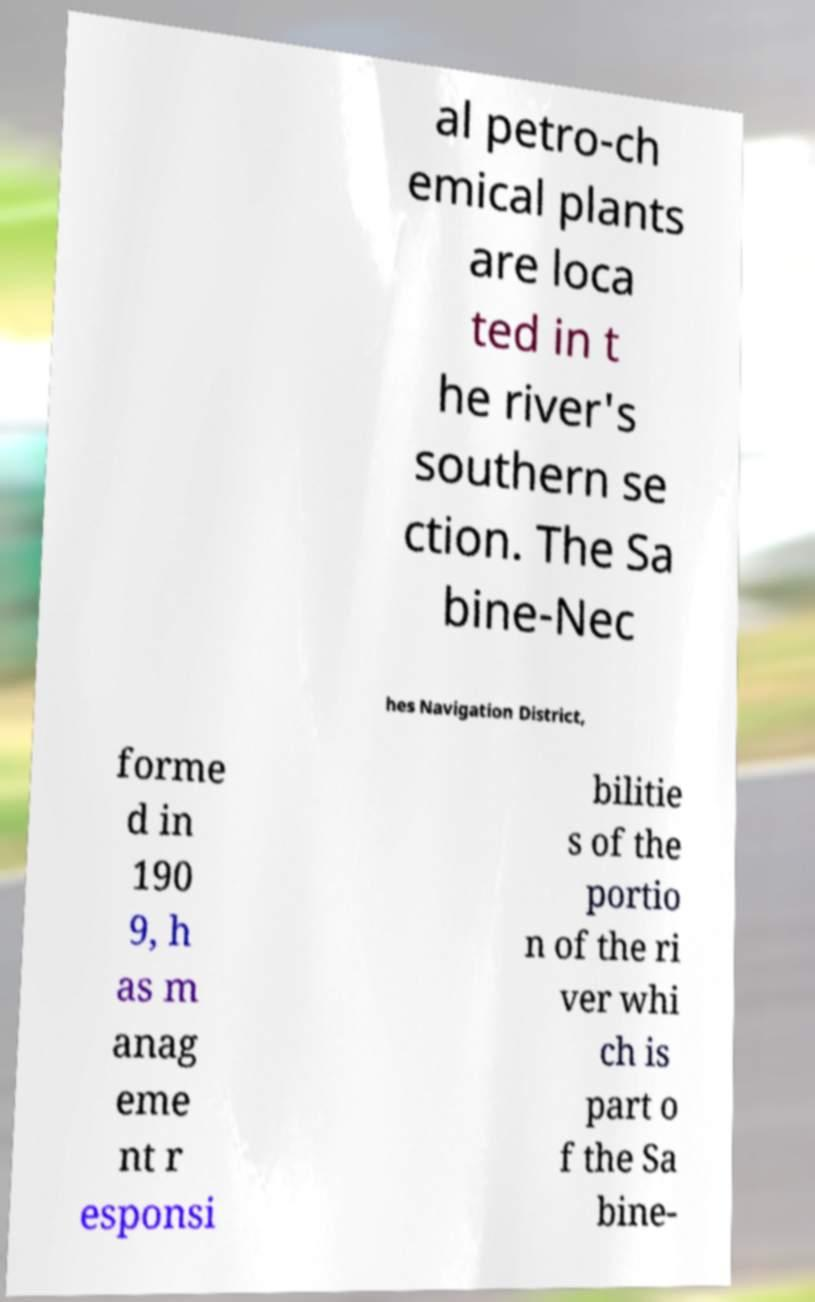What messages or text are displayed in this image? I need them in a readable, typed format. al petro-ch emical plants are loca ted in t he river's southern se ction. The Sa bine-Nec hes Navigation District, forme d in 190 9, h as m anag eme nt r esponsi bilitie s of the portio n of the ri ver whi ch is part o f the Sa bine- 